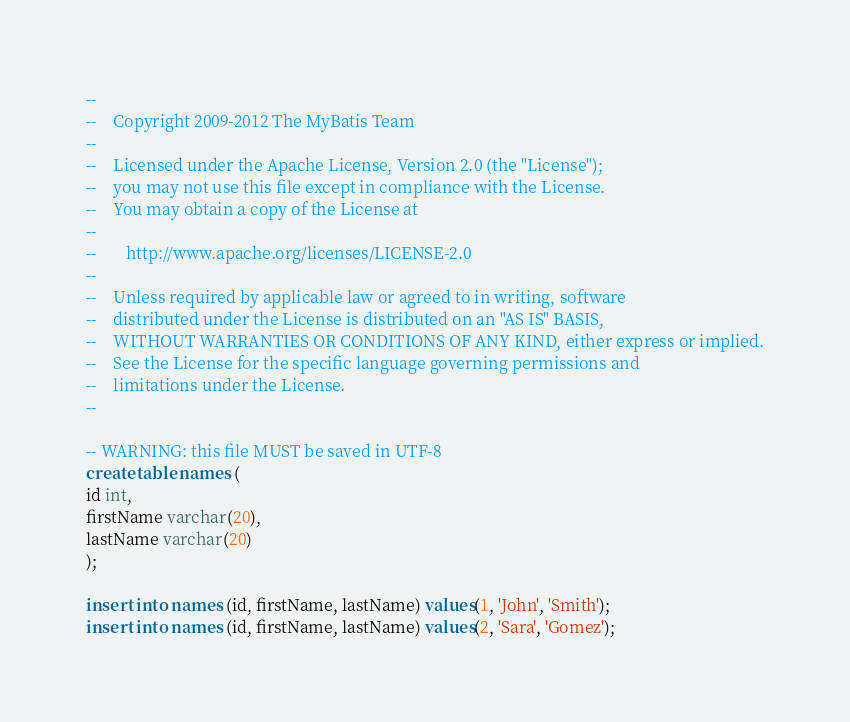Convert code to text. <code><loc_0><loc_0><loc_500><loc_500><_SQL_>--
--    Copyright 2009-2012 The MyBatis Team
--
--    Licensed under the Apache License, Version 2.0 (the "License");
--    you may not use this file except in compliance with the License.
--    You may obtain a copy of the License at
--
--       http://www.apache.org/licenses/LICENSE-2.0
--
--    Unless required by applicable law or agreed to in writing, software
--    distributed under the License is distributed on an "AS IS" BASIS,
--    WITHOUT WARRANTIES OR CONDITIONS OF ANY KIND, either express or implied.
--    See the License for the specific language governing permissions and
--    limitations under the License.
--

-- WARNING: this file MUST be saved in UTF-8
create table names (
id int,
firstName varchar(20),
lastName varchar(20)
);

insert into names (id, firstName, lastName) values(1, 'John', 'Smith');
insert into names (id, firstName, lastName) values(2, 'Sara', 'Gomez');
</code> 